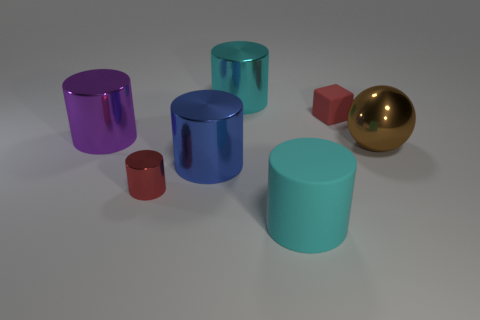Add 1 large red rubber spheres. How many objects exist? 8 Subtract 0 blue blocks. How many objects are left? 7 Subtract all cubes. How many objects are left? 6 Subtract 1 balls. How many balls are left? 0 Subtract all red cylinders. Subtract all red spheres. How many cylinders are left? 4 Subtract all gray blocks. How many blue cylinders are left? 1 Subtract all tiny shiny things. Subtract all brown things. How many objects are left? 5 Add 4 brown objects. How many brown objects are left? 5 Add 1 big brown metallic spheres. How many big brown metallic spheres exist? 2 Subtract all blue cylinders. How many cylinders are left? 4 